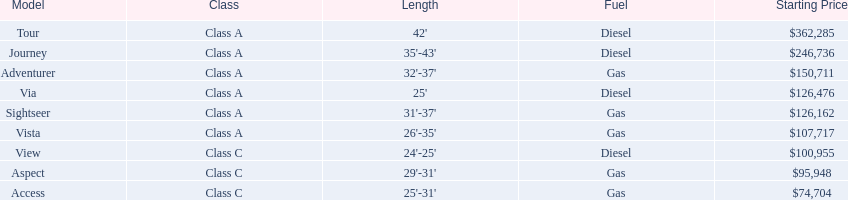What are all the class a models of the winnebago industries? Tour, Journey, Adventurer, Via, Sightseer, Vista. Of those class a models, which has the highest starting price? Tour. 